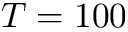<formula> <loc_0><loc_0><loc_500><loc_500>T = 1 0 0</formula> 